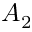Convert formula to latex. <formula><loc_0><loc_0><loc_500><loc_500>A _ { 2 }</formula> 